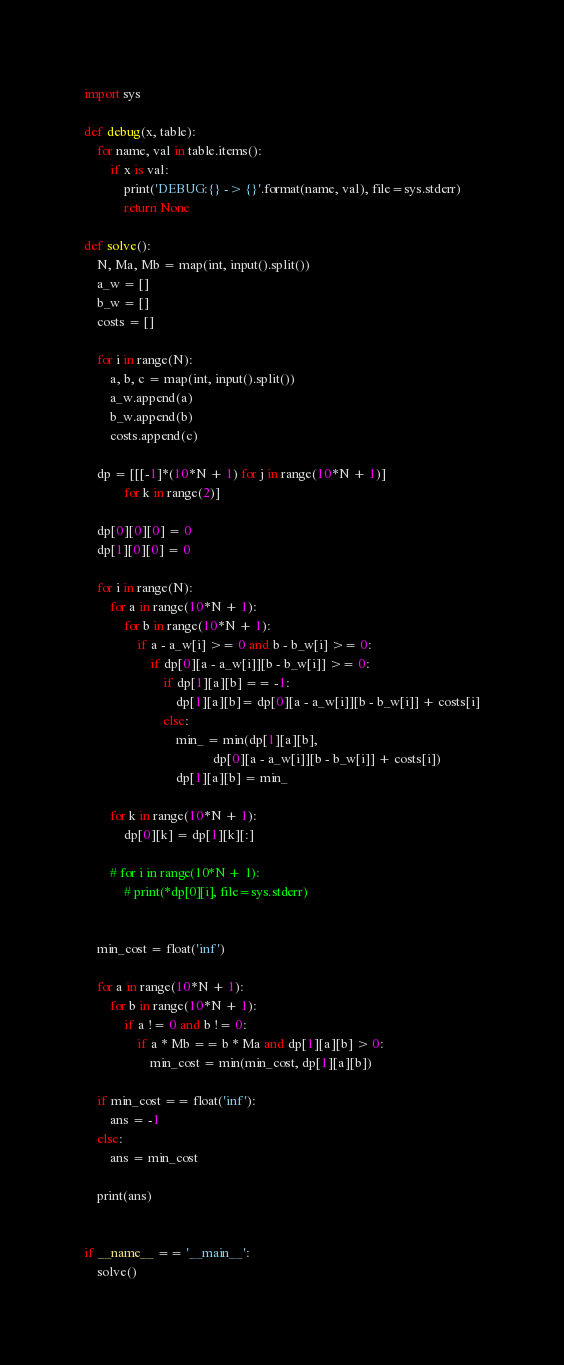<code> <loc_0><loc_0><loc_500><loc_500><_Python_>import sys

def debug(x, table):
    for name, val in table.items():
        if x is val:
            print('DEBUG:{} -> {}'.format(name, val), file=sys.stderr)
            return None

def solve():
    N, Ma, Mb = map(int, input().split())
    a_w = []
    b_w = []
    costs = []

    for i in range(N):
        a, b, c = map(int, input().split())
        a_w.append(a)
        b_w.append(b)
        costs.append(c)

    dp = [[[-1]*(10*N + 1) for j in range(10*N + 1)]
            for k in range(2)]

    dp[0][0][0] = 0
    dp[1][0][0] = 0

    for i in range(N):
        for a in range(10*N + 1):
            for b in range(10*N + 1):
                if a - a_w[i] >= 0 and b - b_w[i] >= 0:
                    if dp[0][a - a_w[i]][b - b_w[i]] >= 0:
                        if dp[1][a][b] == -1:
                            dp[1][a][b]= dp[0][a - a_w[i]][b - b_w[i]] + costs[i]
                        else:
                            min_ = min(dp[1][a][b],
                                       dp[0][a - a_w[i]][b - b_w[i]] + costs[i])
                            dp[1][a][b] = min_
        
        for k in range(10*N + 1):
            dp[0][k] = dp[1][k][:]

        # for i in range(10*N + 1):
            # print(*dp[0][i], file=sys.stderr)


    min_cost = float('inf')

    for a in range(10*N + 1):
        for b in range(10*N + 1):
            if a != 0 and b != 0:
                if a * Mb == b * Ma and dp[1][a][b] > 0:
                    min_cost = min(min_cost, dp[1][a][b])

    if min_cost == float('inf'):
        ans = -1
    else:
        ans = min_cost

    print(ans)


if __name__ == '__main__':
    solve()</code> 